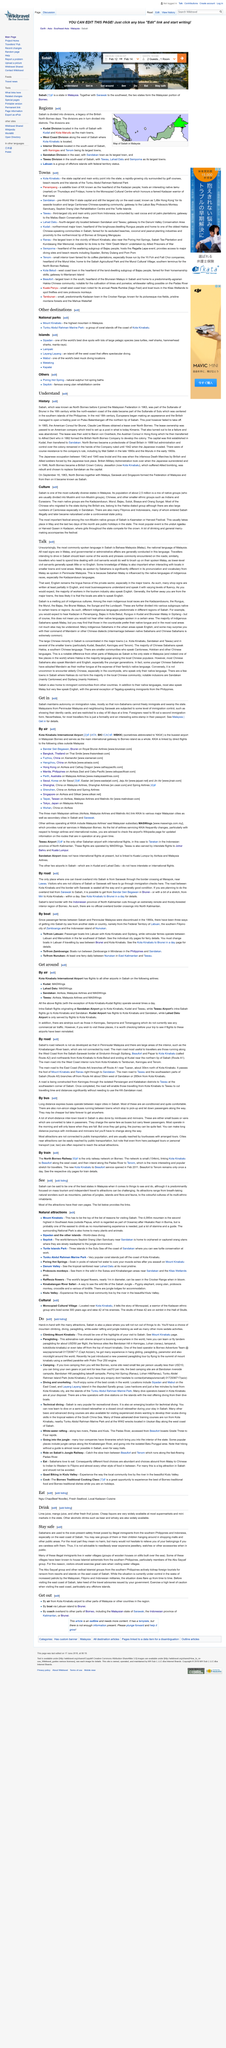Draw attention to some important aspects in this diagram. Visitors who are not citizens of Sabah or Sarawak should take note that they will have to pass immigration checks upon arrival at the Mulu National Park. The passenger boat crossing between Sabah and Peninsular Malaysia was interrupted in the 1990s. The only way to travel overland to Sabah from Sarawak is through Merapok on the border. 